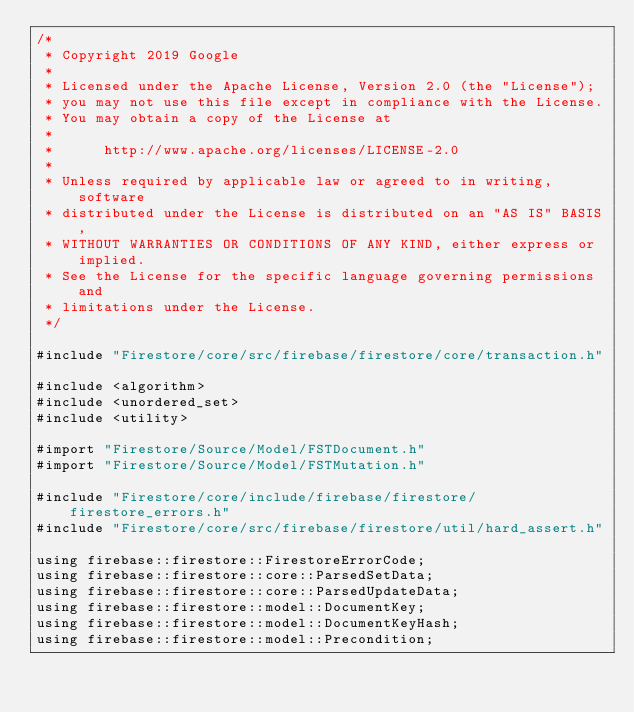Convert code to text. <code><loc_0><loc_0><loc_500><loc_500><_ObjectiveC_>/*
 * Copyright 2019 Google
 *
 * Licensed under the Apache License, Version 2.0 (the "License");
 * you may not use this file except in compliance with the License.
 * You may obtain a copy of the License at
 *
 *      http://www.apache.org/licenses/LICENSE-2.0
 *
 * Unless required by applicable law or agreed to in writing, software
 * distributed under the License is distributed on an "AS IS" BASIS,
 * WITHOUT WARRANTIES OR CONDITIONS OF ANY KIND, either express or implied.
 * See the License for the specific language governing permissions and
 * limitations under the License.
 */

#include "Firestore/core/src/firebase/firestore/core/transaction.h"

#include <algorithm>
#include <unordered_set>
#include <utility>

#import "Firestore/Source/Model/FSTDocument.h"
#import "Firestore/Source/Model/FSTMutation.h"

#include "Firestore/core/include/firebase/firestore/firestore_errors.h"
#include "Firestore/core/src/firebase/firestore/util/hard_assert.h"

using firebase::firestore::FirestoreErrorCode;
using firebase::firestore::core::ParsedSetData;
using firebase::firestore::core::ParsedUpdateData;
using firebase::firestore::model::DocumentKey;
using firebase::firestore::model::DocumentKeyHash;
using firebase::firestore::model::Precondition;</code> 